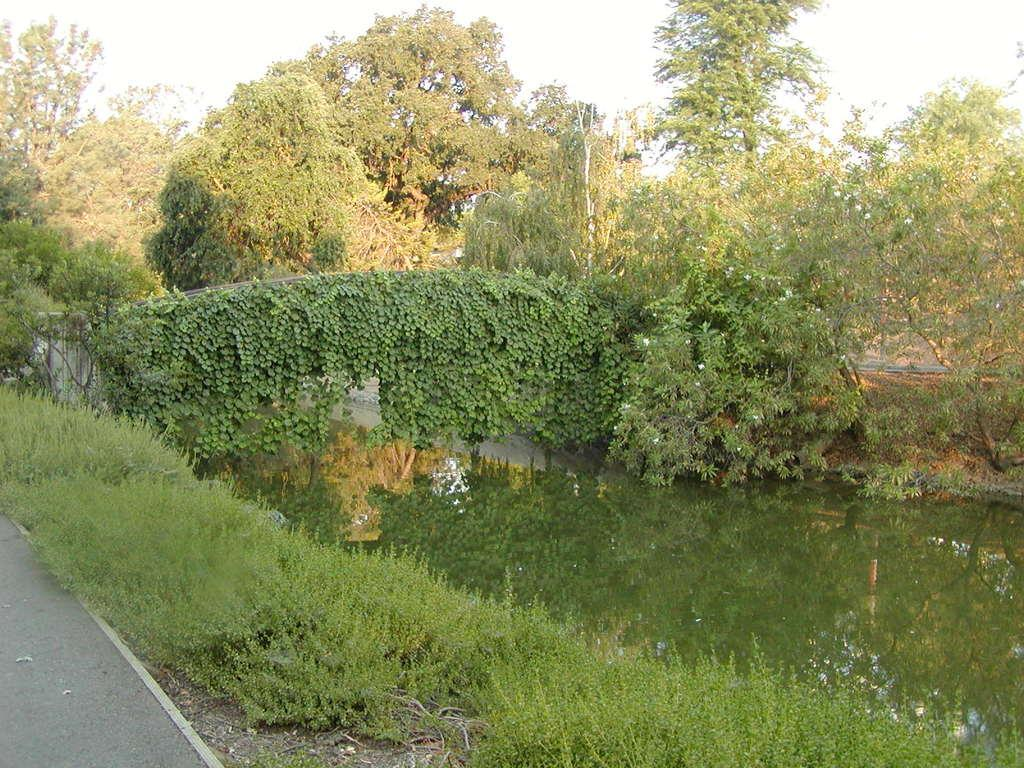What type of vegetation can be seen in the image? There are trees in the image. What else can be seen in the image besides trees? There is water, grass, and the sky visible in the image. Can you hear the bell ringing in the image? There is no bell present in the image, so it cannot be heard. 